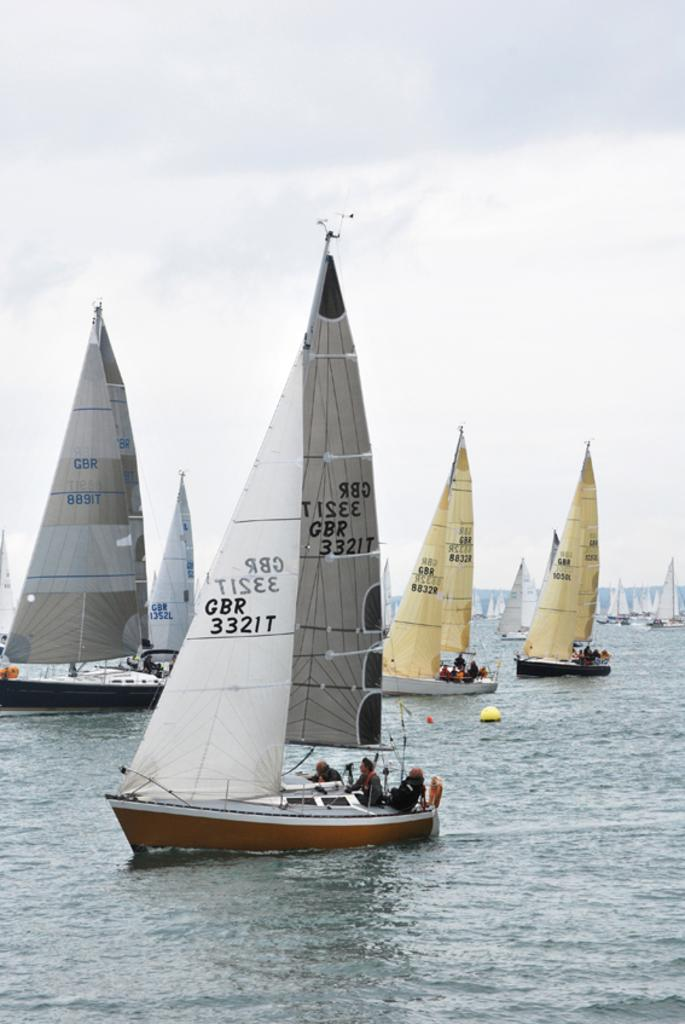<image>
Describe the image concisely. One of the several sailboats has the number GBR 332IT on its sail 